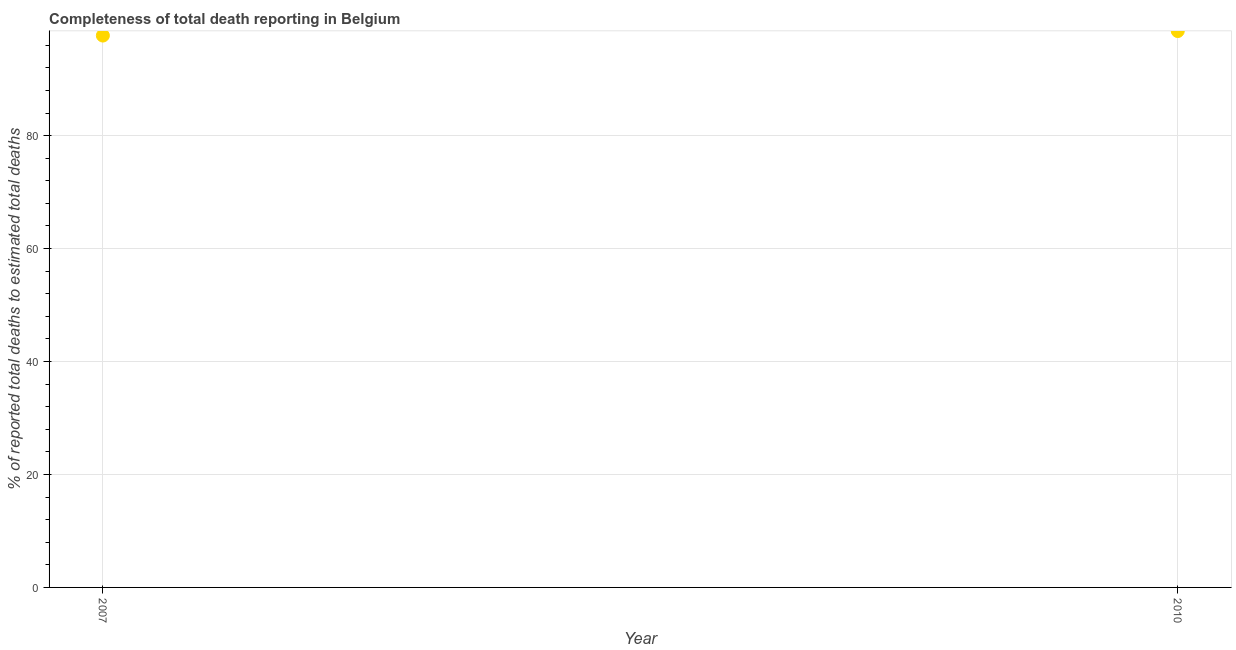What is the completeness of total death reports in 2007?
Offer a terse response. 97.72. Across all years, what is the maximum completeness of total death reports?
Your answer should be very brief. 98.52. Across all years, what is the minimum completeness of total death reports?
Offer a very short reply. 97.72. In which year was the completeness of total death reports maximum?
Make the answer very short. 2010. In which year was the completeness of total death reports minimum?
Provide a succinct answer. 2007. What is the sum of the completeness of total death reports?
Ensure brevity in your answer.  196.24. What is the difference between the completeness of total death reports in 2007 and 2010?
Your answer should be compact. -0.8. What is the average completeness of total death reports per year?
Your response must be concise. 98.12. What is the median completeness of total death reports?
Provide a short and direct response. 98.12. In how many years, is the completeness of total death reports greater than 4 %?
Give a very brief answer. 2. Do a majority of the years between 2007 and 2010 (inclusive) have completeness of total death reports greater than 20 %?
Give a very brief answer. Yes. What is the ratio of the completeness of total death reports in 2007 to that in 2010?
Ensure brevity in your answer.  0.99. Is the completeness of total death reports in 2007 less than that in 2010?
Offer a very short reply. Yes. In how many years, is the completeness of total death reports greater than the average completeness of total death reports taken over all years?
Your answer should be compact. 1. How many dotlines are there?
Ensure brevity in your answer.  1. What is the difference between two consecutive major ticks on the Y-axis?
Provide a succinct answer. 20. Does the graph contain grids?
Your response must be concise. Yes. What is the title of the graph?
Offer a terse response. Completeness of total death reporting in Belgium. What is the label or title of the Y-axis?
Your answer should be very brief. % of reported total deaths to estimated total deaths. What is the % of reported total deaths to estimated total deaths in 2007?
Your response must be concise. 97.72. What is the % of reported total deaths to estimated total deaths in 2010?
Offer a terse response. 98.52. What is the difference between the % of reported total deaths to estimated total deaths in 2007 and 2010?
Give a very brief answer. -0.8. 